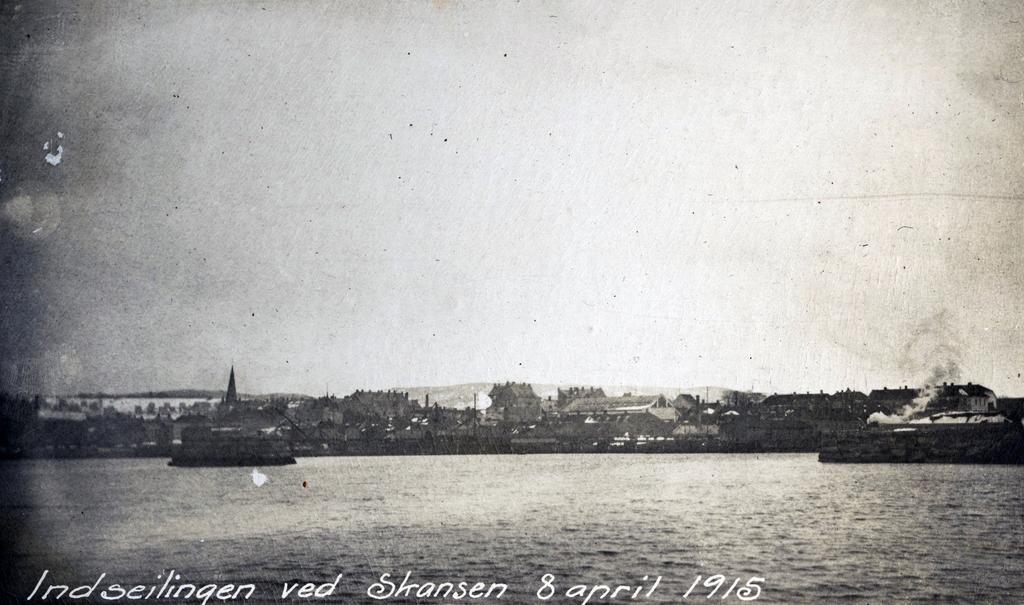Could you give a brief overview of what you see in this image? This is a black and white image. At the bottom, I can see the water. In the background there are many buildings and trees. At the top of the image I can see the sky. At the bottom of this image there is some edited text. 